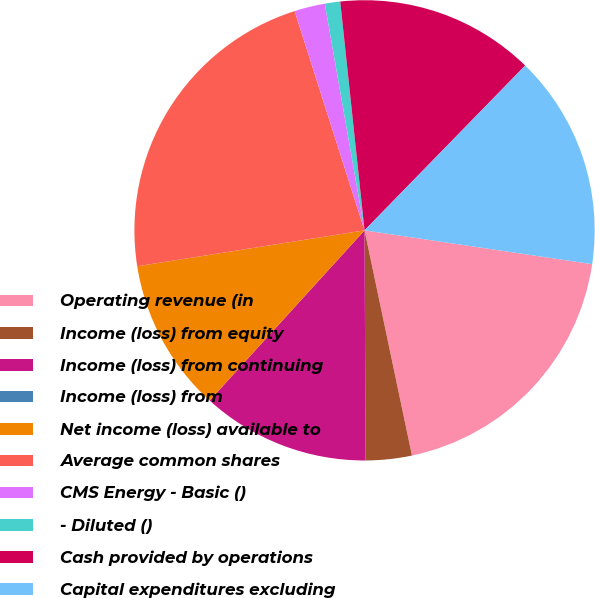Convert chart. <chart><loc_0><loc_0><loc_500><loc_500><pie_chart><fcel>Operating revenue (in<fcel>Income (loss) from equity<fcel>Income (loss) from continuing<fcel>Income (loss) from<fcel>Net income (loss) available to<fcel>Average common shares<fcel>CMS Energy - Basic ()<fcel>- Diluted ()<fcel>Cash provided by operations<fcel>Capital expenditures excluding<nl><fcel>19.35%<fcel>3.23%<fcel>11.83%<fcel>0.0%<fcel>10.75%<fcel>22.58%<fcel>2.15%<fcel>1.08%<fcel>13.98%<fcel>15.05%<nl></chart> 